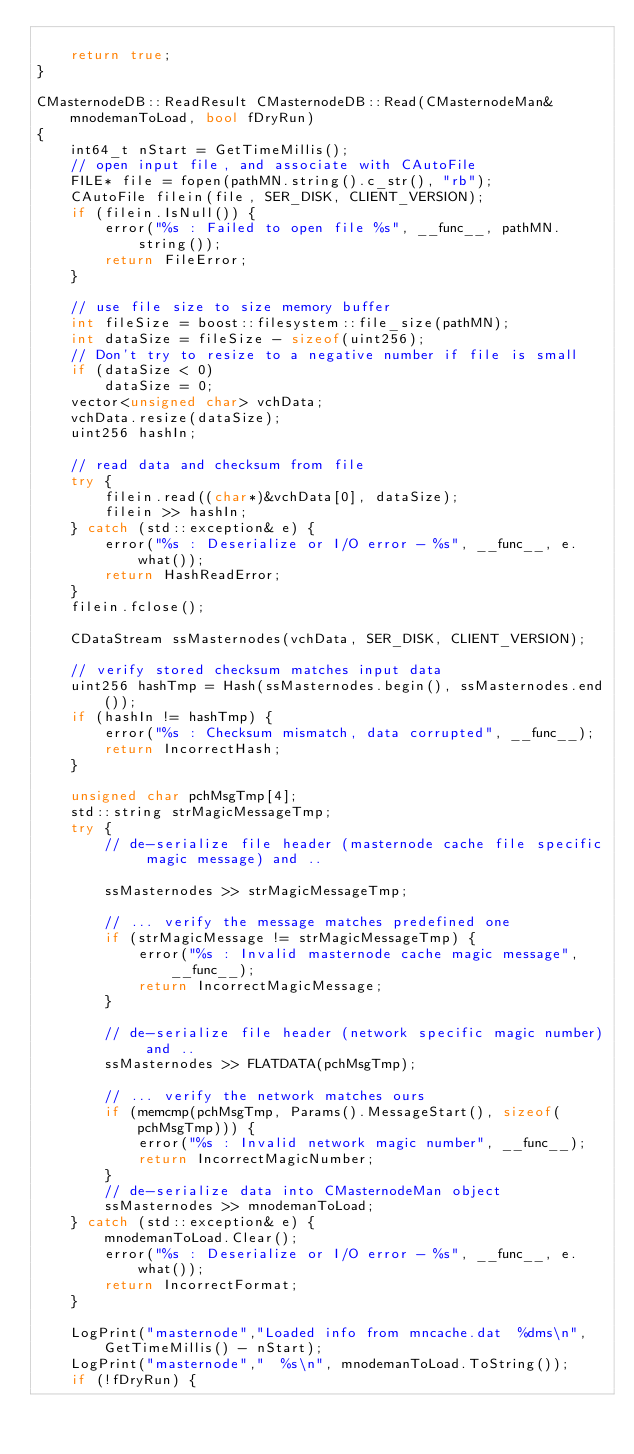Convert code to text. <code><loc_0><loc_0><loc_500><loc_500><_C++_>
    return true;
}

CMasternodeDB::ReadResult CMasternodeDB::Read(CMasternodeMan& mnodemanToLoad, bool fDryRun)
{
    int64_t nStart = GetTimeMillis();
    // open input file, and associate with CAutoFile
    FILE* file = fopen(pathMN.string().c_str(), "rb");
    CAutoFile filein(file, SER_DISK, CLIENT_VERSION);
    if (filein.IsNull()) {
        error("%s : Failed to open file %s", __func__, pathMN.string());
        return FileError;
    }

    // use file size to size memory buffer
    int fileSize = boost::filesystem::file_size(pathMN);
    int dataSize = fileSize - sizeof(uint256);
    // Don't try to resize to a negative number if file is small
    if (dataSize < 0)
        dataSize = 0;
    vector<unsigned char> vchData;
    vchData.resize(dataSize);
    uint256 hashIn;

    // read data and checksum from file
    try {
        filein.read((char*)&vchData[0], dataSize);
        filein >> hashIn;
    } catch (std::exception& e) {
        error("%s : Deserialize or I/O error - %s", __func__, e.what());
        return HashReadError;
    }
    filein.fclose();

    CDataStream ssMasternodes(vchData, SER_DISK, CLIENT_VERSION);

    // verify stored checksum matches input data
    uint256 hashTmp = Hash(ssMasternodes.begin(), ssMasternodes.end());
    if (hashIn != hashTmp) {
        error("%s : Checksum mismatch, data corrupted", __func__);
        return IncorrectHash;
    }

    unsigned char pchMsgTmp[4];
    std::string strMagicMessageTmp;
    try {
        // de-serialize file header (masternode cache file specific magic message) and ..

        ssMasternodes >> strMagicMessageTmp;

        // ... verify the message matches predefined one
        if (strMagicMessage != strMagicMessageTmp) {
            error("%s : Invalid masternode cache magic message", __func__);
            return IncorrectMagicMessage;
        }

        // de-serialize file header (network specific magic number) and ..
        ssMasternodes >> FLATDATA(pchMsgTmp);

        // ... verify the network matches ours
        if (memcmp(pchMsgTmp, Params().MessageStart(), sizeof(pchMsgTmp))) {
            error("%s : Invalid network magic number", __func__);
            return IncorrectMagicNumber;
        }
        // de-serialize data into CMasternodeMan object
        ssMasternodes >> mnodemanToLoad;
    } catch (std::exception& e) {
        mnodemanToLoad.Clear();
        error("%s : Deserialize or I/O error - %s", __func__, e.what());
        return IncorrectFormat;
    }

    LogPrint("masternode","Loaded info from mncache.dat  %dms\n", GetTimeMillis() - nStart);
    LogPrint("masternode","  %s\n", mnodemanToLoad.ToString());
    if (!fDryRun) {</code> 